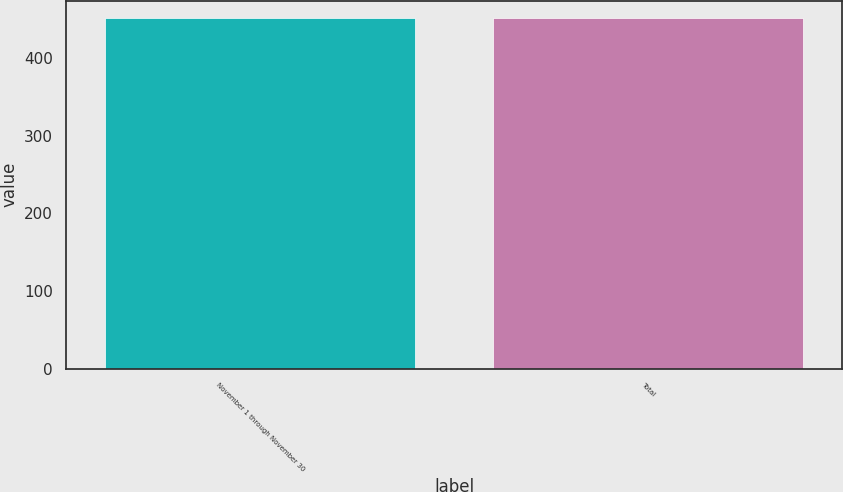Convert chart to OTSL. <chart><loc_0><loc_0><loc_500><loc_500><bar_chart><fcel>November 1 through November 30<fcel>Total<nl><fcel>451<fcel>451.1<nl></chart> 